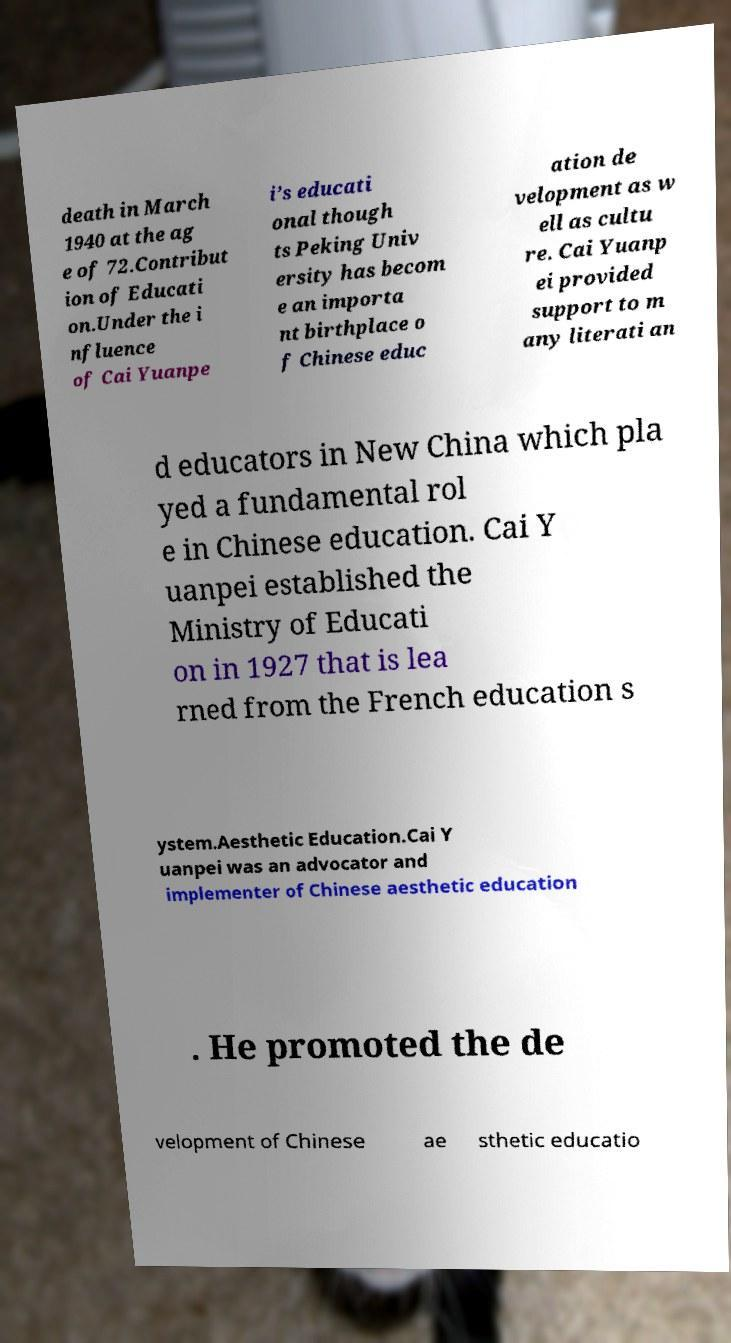Please read and relay the text visible in this image. What does it say? death in March 1940 at the ag e of 72.Contribut ion of Educati on.Under the i nfluence of Cai Yuanpe i’s educati onal though ts Peking Univ ersity has becom e an importa nt birthplace o f Chinese educ ation de velopment as w ell as cultu re. Cai Yuanp ei provided support to m any literati an d educators in New China which pla yed a fundamental rol e in Chinese education. Cai Y uanpei established the Ministry of Educati on in 1927 that is lea rned from the French education s ystem.Aesthetic Education.Cai Y uanpei was an advocator and implementer of Chinese aesthetic education . He promoted the de velopment of Chinese ae sthetic educatio 